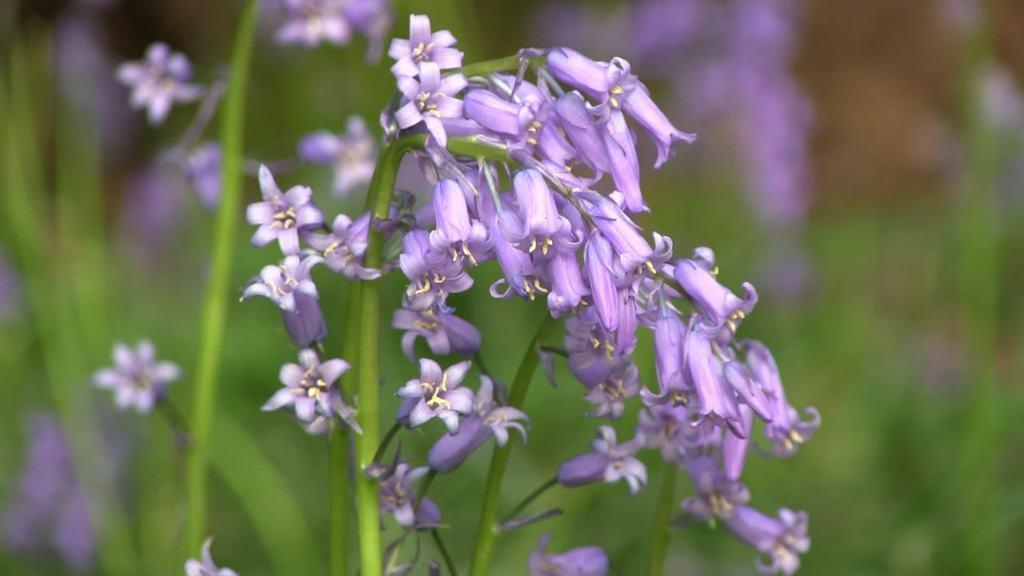What is present in the image? There is a plant in the image. What can be observed about the plant? The plant has flowers. What type of sweater is the plant wearing in the image? There is no sweater present in the image, as the subject is a plant and not a person. 